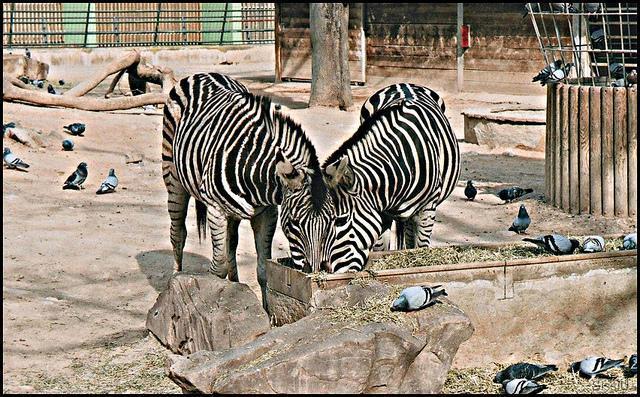How many zebra heads are in the picture?
Give a very brief answer. 2. How many zebras can be seen?
Give a very brief answer. 2. How many trains are in the picture?
Give a very brief answer. 0. 